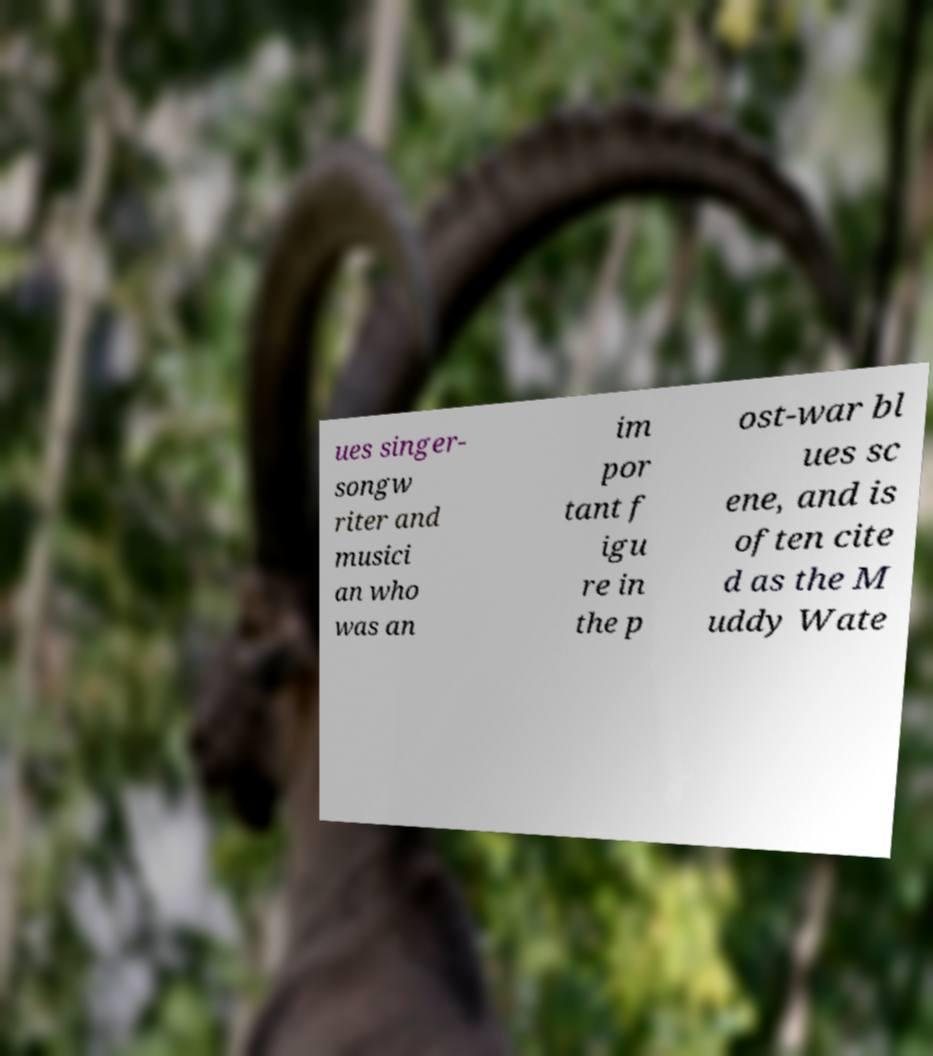I need the written content from this picture converted into text. Can you do that? ues singer- songw riter and musici an who was an im por tant f igu re in the p ost-war bl ues sc ene, and is often cite d as the M uddy Wate 